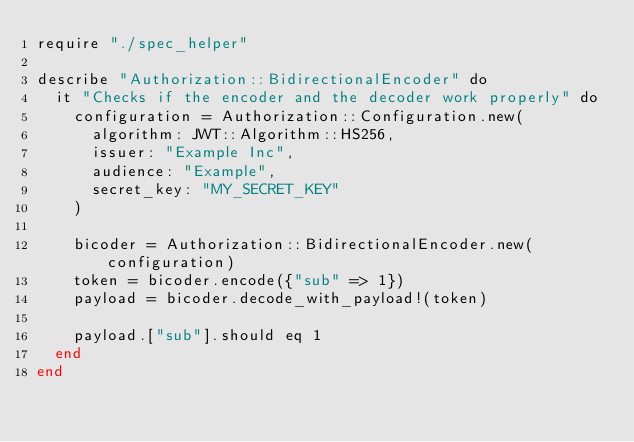<code> <loc_0><loc_0><loc_500><loc_500><_Crystal_>require "./spec_helper"

describe "Authorization::BidirectionalEncoder" do
  it "Checks if the encoder and the decoder work properly" do
    configuration = Authorization::Configuration.new(
      algorithm: JWT::Algorithm::HS256,
      issuer: "Example Inc",
      audience: "Example",
      secret_key: "MY_SECRET_KEY"
    )

    bicoder = Authorization::BidirectionalEncoder.new(configuration)
    token = bicoder.encode({"sub" => 1})
    payload = bicoder.decode_with_payload!(token)

    payload.["sub"].should eq 1
  end
end
</code> 